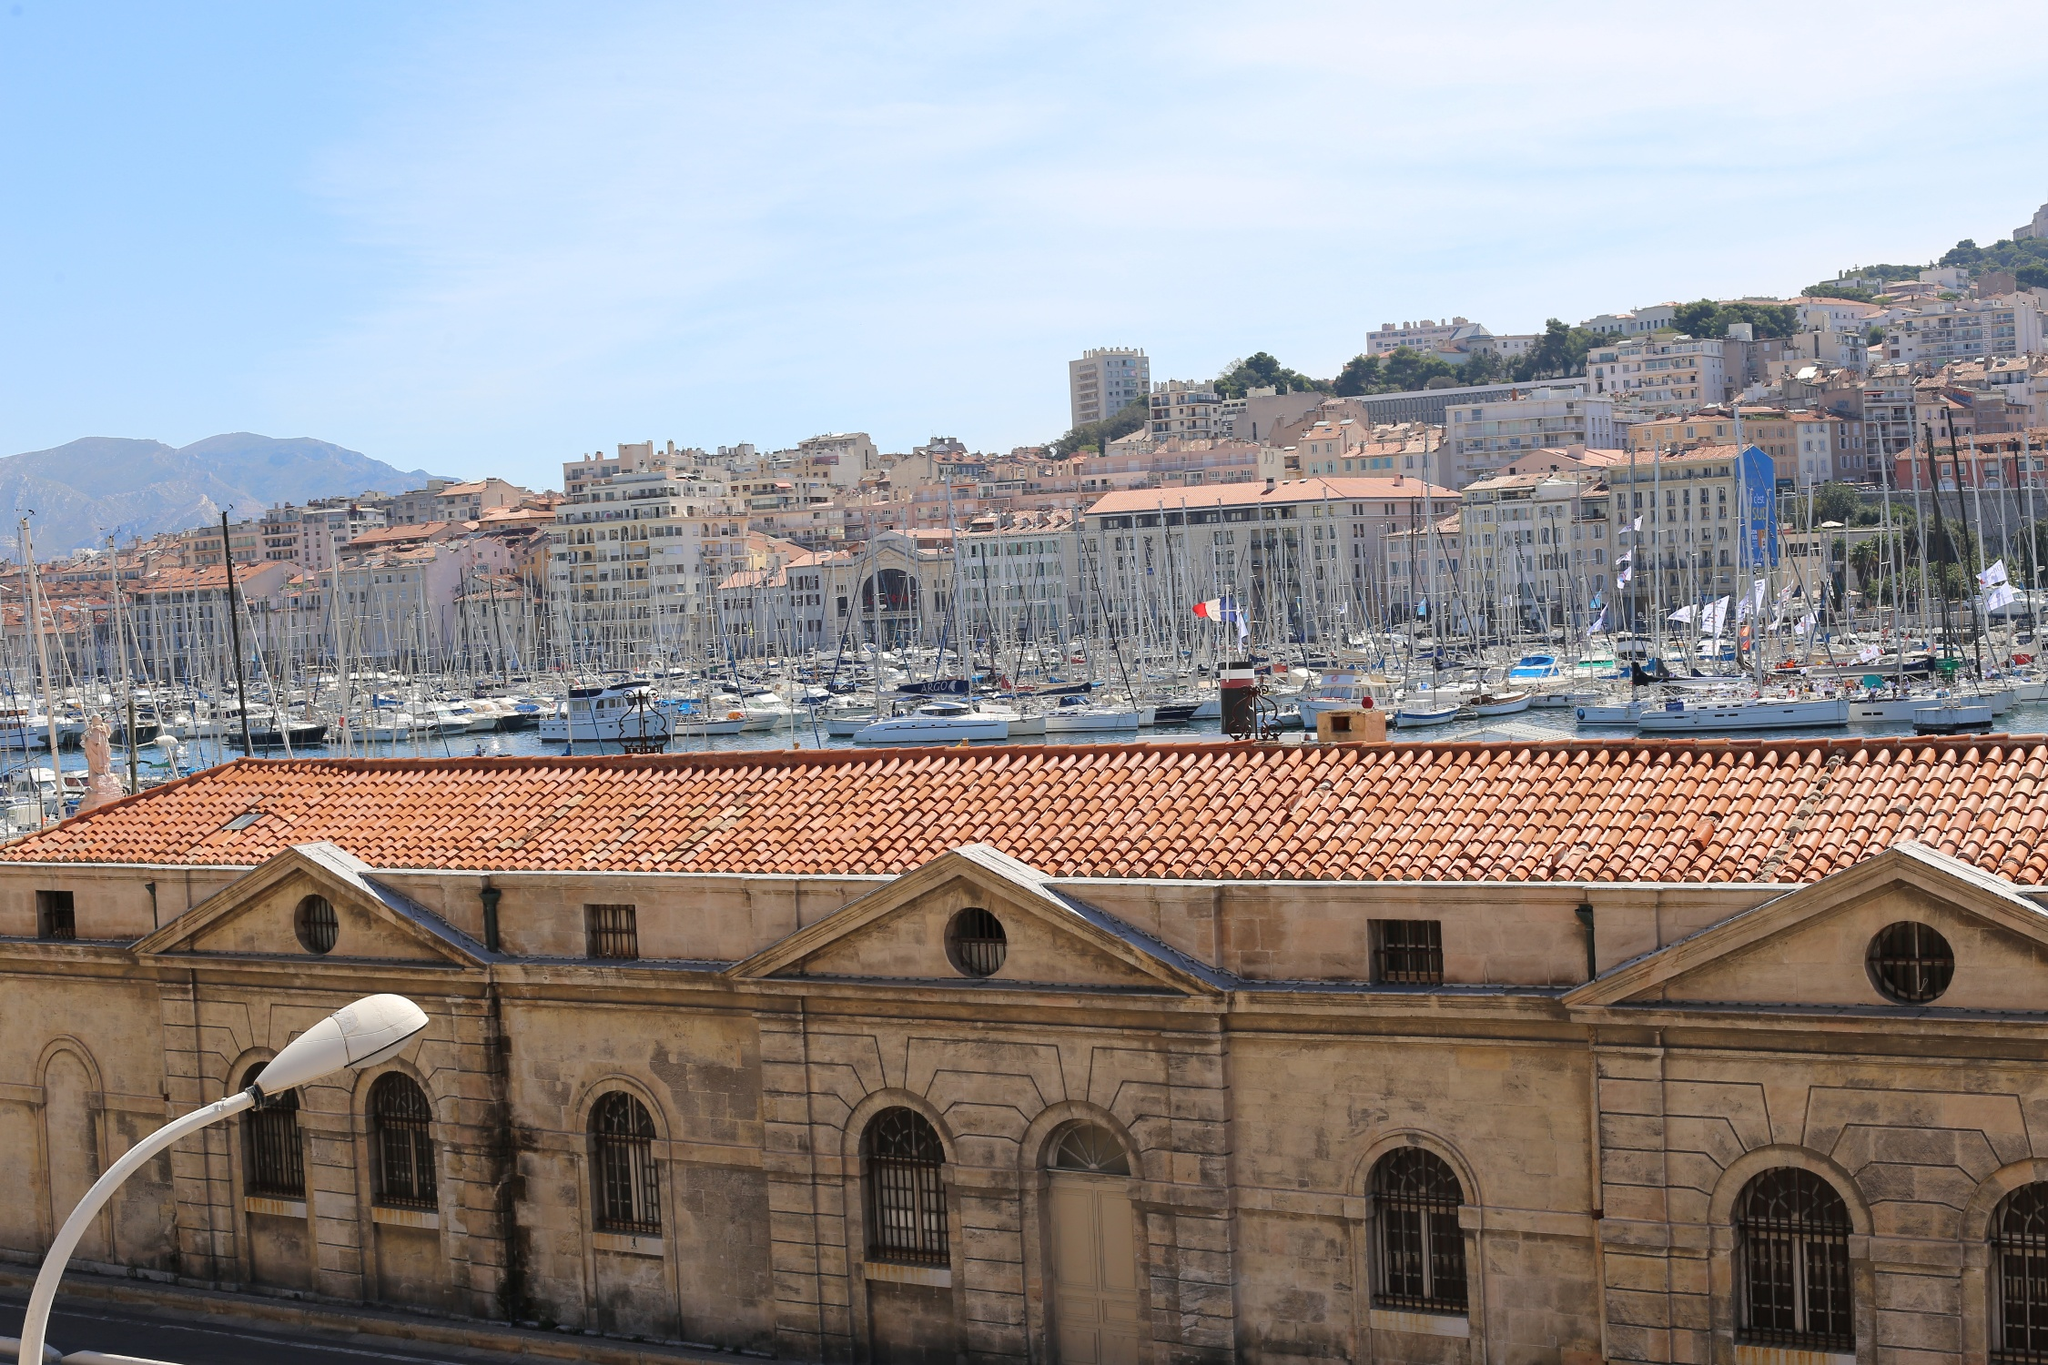Suppose the historic building in the foreground could talk. What stories would it tell about the Old Port of Marseille? If the historic building in the foreground could speak, it would be a storyteller of maritime tales spanning centuries. It might begin with tales of ancient fishermen setting out at dawn, their boats laden with hope and nets ready for the day's catch. It could recount the bustling era of merchants and traders when the port was a hub of commerce, with goods from all over the world arriving and departing. Stories of sailors and adventurers, setting sail to distant lands, or returning with tales of exotic places, would fill its repertoire. During times of conflict, it would recall the sight of naval ships, the echoes of cannon fire in defense of the city. More recent memories might include the laughter of tourists, the vivid colors of festivals, and the tranquil silence of peaceful mornings. The building, with its enduring presence, would be a silent witness to the ever-evolving life around the Old Port of Marseille, blending the past with the present. 